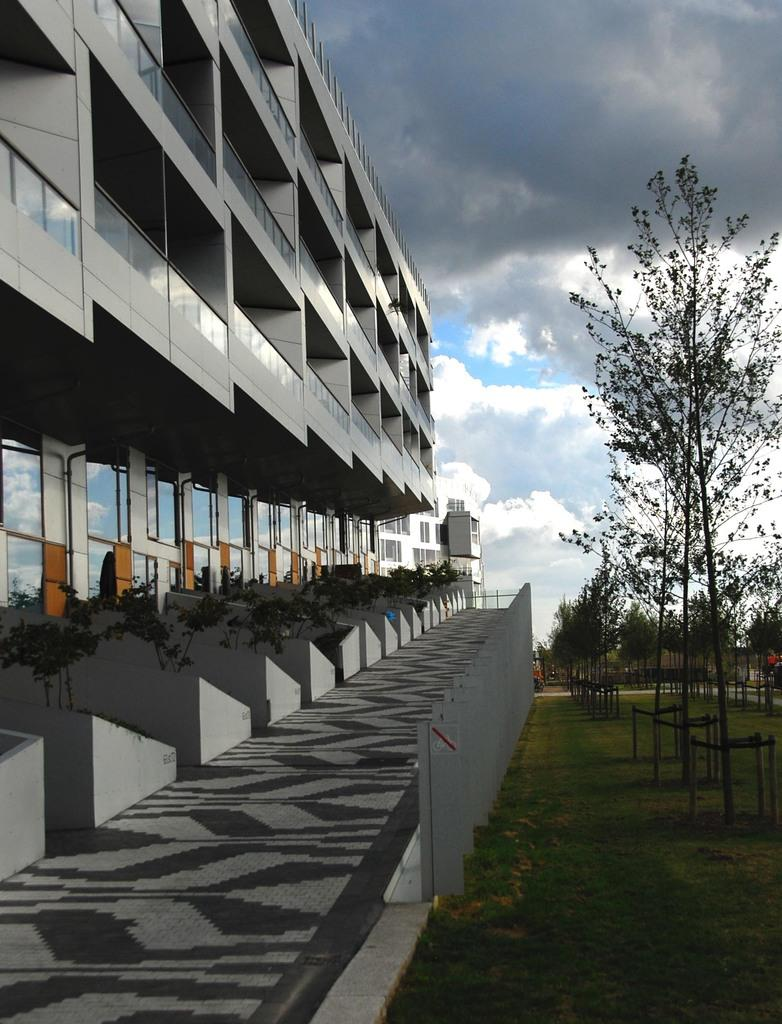What type of structures can be seen in the image? There are buildings in the image. What other natural elements are present in the image? There are plants, trees, and grass visible in the image. What architectural feature can be seen in the image? There is a wall in the image. What is visible in the background of the image? The sky is visible in the background of the image, and clouds are present in the sky. What type of produce is being harvested by the toad in the image? There is no toad present in the image, and therefore no produce is being harvested. How many cubs can be seen playing with the plants in the image? There are no cubs present in the image; the focus is on plants, trees, and grass. 